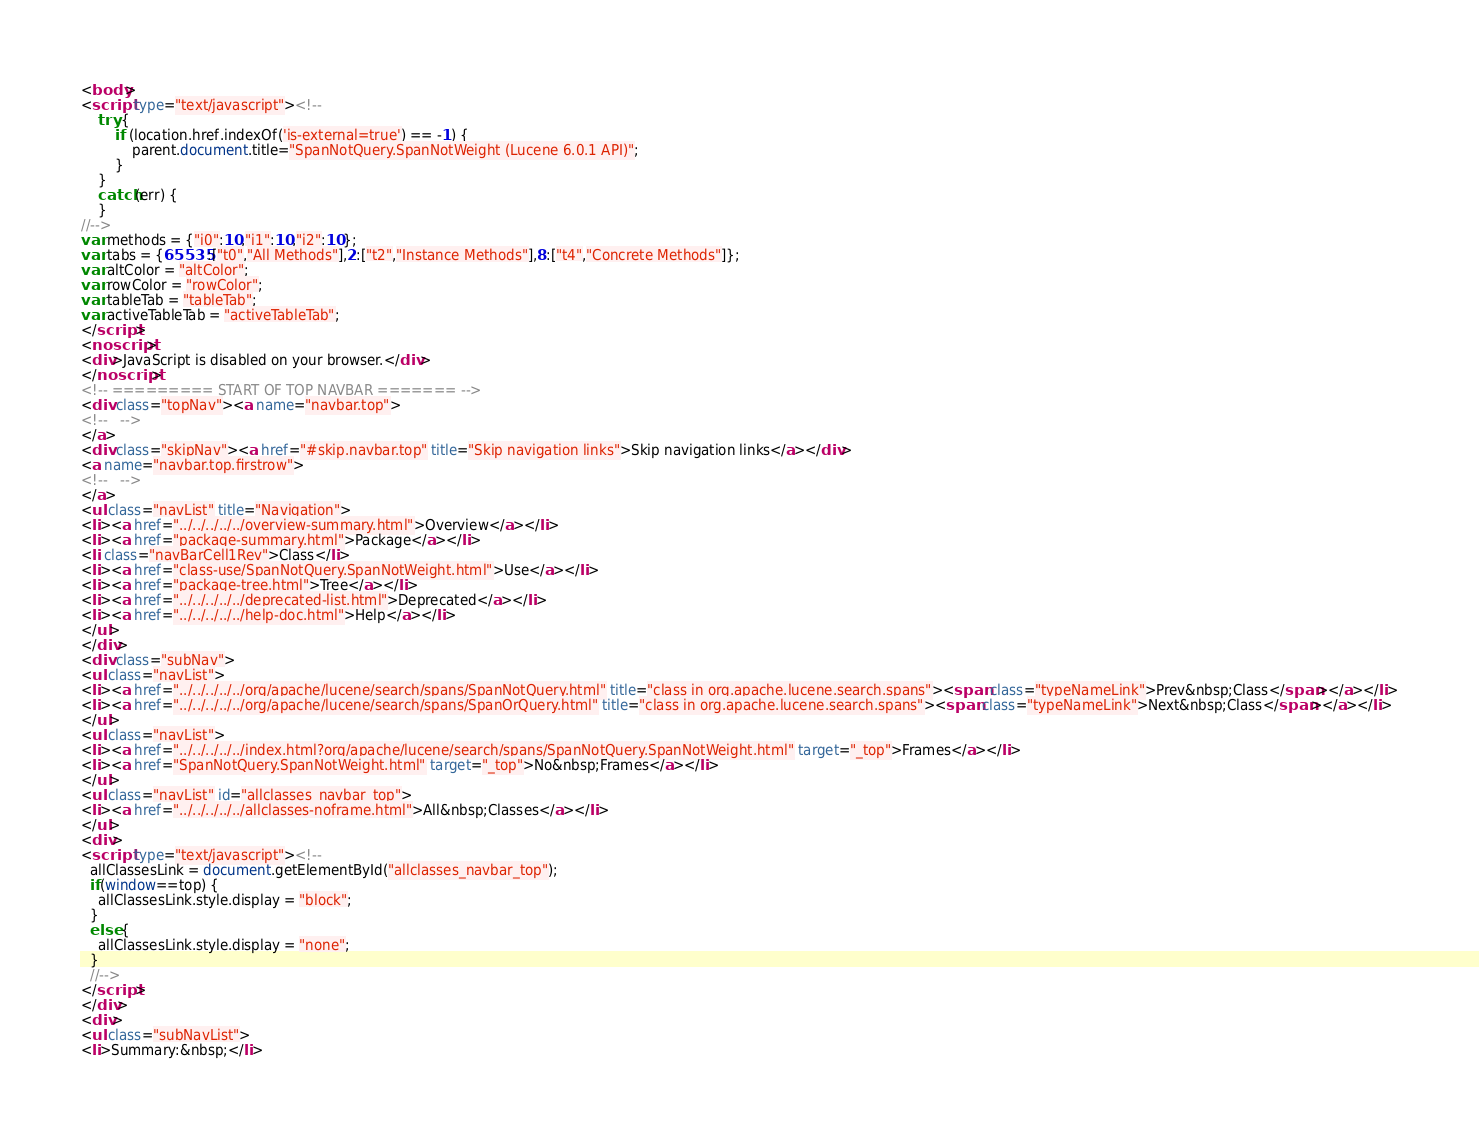Convert code to text. <code><loc_0><loc_0><loc_500><loc_500><_HTML_><body>
<script type="text/javascript"><!--
    try {
        if (location.href.indexOf('is-external=true') == -1) {
            parent.document.title="SpanNotQuery.SpanNotWeight (Lucene 6.0.1 API)";
        }
    }
    catch(err) {
    }
//-->
var methods = {"i0":10,"i1":10,"i2":10};
var tabs = {65535:["t0","All Methods"],2:["t2","Instance Methods"],8:["t4","Concrete Methods"]};
var altColor = "altColor";
var rowColor = "rowColor";
var tableTab = "tableTab";
var activeTableTab = "activeTableTab";
</script>
<noscript>
<div>JavaScript is disabled on your browser.</div>
</noscript>
<!-- ========= START OF TOP NAVBAR ======= -->
<div class="topNav"><a name="navbar.top">
<!--   -->
</a>
<div class="skipNav"><a href="#skip.navbar.top" title="Skip navigation links">Skip navigation links</a></div>
<a name="navbar.top.firstrow">
<!--   -->
</a>
<ul class="navList" title="Navigation">
<li><a href="../../../../../overview-summary.html">Overview</a></li>
<li><a href="package-summary.html">Package</a></li>
<li class="navBarCell1Rev">Class</li>
<li><a href="class-use/SpanNotQuery.SpanNotWeight.html">Use</a></li>
<li><a href="package-tree.html">Tree</a></li>
<li><a href="../../../../../deprecated-list.html">Deprecated</a></li>
<li><a href="../../../../../help-doc.html">Help</a></li>
</ul>
</div>
<div class="subNav">
<ul class="navList">
<li><a href="../../../../../org/apache/lucene/search/spans/SpanNotQuery.html" title="class in org.apache.lucene.search.spans"><span class="typeNameLink">Prev&nbsp;Class</span></a></li>
<li><a href="../../../../../org/apache/lucene/search/spans/SpanOrQuery.html" title="class in org.apache.lucene.search.spans"><span class="typeNameLink">Next&nbsp;Class</span></a></li>
</ul>
<ul class="navList">
<li><a href="../../../../../index.html?org/apache/lucene/search/spans/SpanNotQuery.SpanNotWeight.html" target="_top">Frames</a></li>
<li><a href="SpanNotQuery.SpanNotWeight.html" target="_top">No&nbsp;Frames</a></li>
</ul>
<ul class="navList" id="allclasses_navbar_top">
<li><a href="../../../../../allclasses-noframe.html">All&nbsp;Classes</a></li>
</ul>
<div>
<script type="text/javascript"><!--
  allClassesLink = document.getElementById("allclasses_navbar_top");
  if(window==top) {
    allClassesLink.style.display = "block";
  }
  else {
    allClassesLink.style.display = "none";
  }
  //-->
</script>
</div>
<div>
<ul class="subNavList">
<li>Summary:&nbsp;</li></code> 